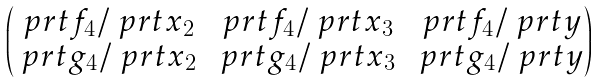<formula> <loc_0><loc_0><loc_500><loc_500>\begin{pmatrix} \ p r t f _ { 4 } / \ p r t x _ { 2 } & \ p r t f _ { 4 } / \ p r t x _ { 3 } & \ p r t f _ { 4 } / \ p r t y \\ \ p r t g _ { 4 } / \ p r t x _ { 2 } & \ p r t g _ { 4 } / \ p r t x _ { 3 } & \ p r t g _ { 4 } / \ p r t y \end{pmatrix}</formula> 